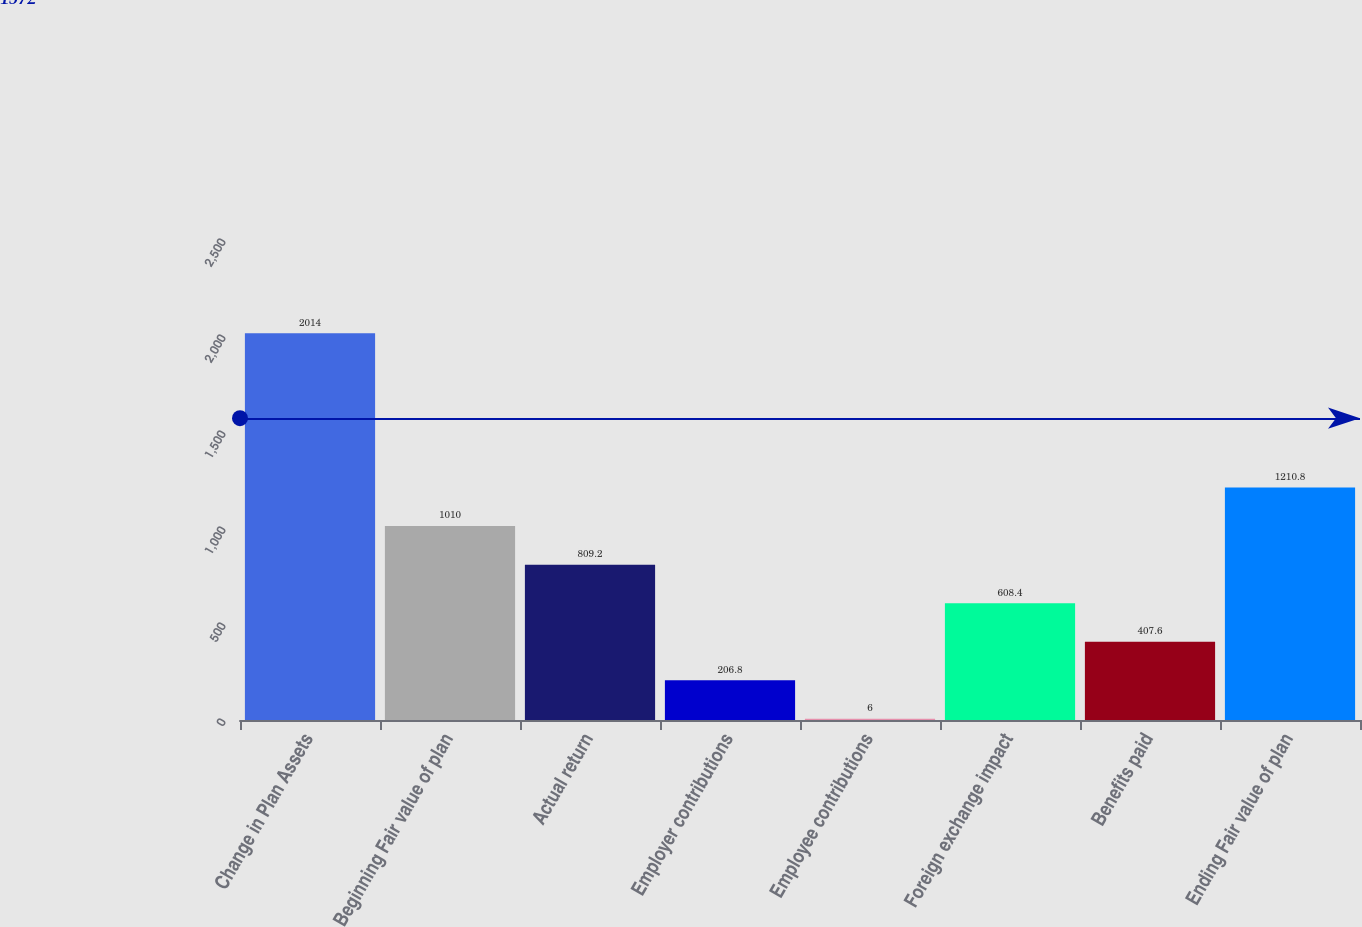<chart> <loc_0><loc_0><loc_500><loc_500><bar_chart><fcel>Change in Plan Assets<fcel>Beginning Fair value of plan<fcel>Actual return<fcel>Employer contributions<fcel>Employee contributions<fcel>Foreign exchange impact<fcel>Benefits paid<fcel>Ending Fair value of plan<nl><fcel>2014<fcel>1010<fcel>809.2<fcel>206.8<fcel>6<fcel>608.4<fcel>407.6<fcel>1210.8<nl></chart> 